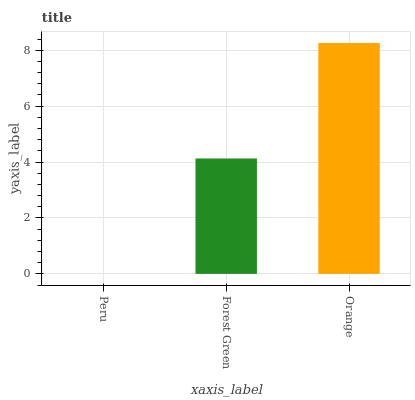Is Peru the minimum?
Answer yes or no. Yes. Is Orange the maximum?
Answer yes or no. Yes. Is Forest Green the minimum?
Answer yes or no. No. Is Forest Green the maximum?
Answer yes or no. No. Is Forest Green greater than Peru?
Answer yes or no. Yes. Is Peru less than Forest Green?
Answer yes or no. Yes. Is Peru greater than Forest Green?
Answer yes or no. No. Is Forest Green less than Peru?
Answer yes or no. No. Is Forest Green the high median?
Answer yes or no. Yes. Is Forest Green the low median?
Answer yes or no. Yes. Is Peru the high median?
Answer yes or no. No. Is Peru the low median?
Answer yes or no. No. 